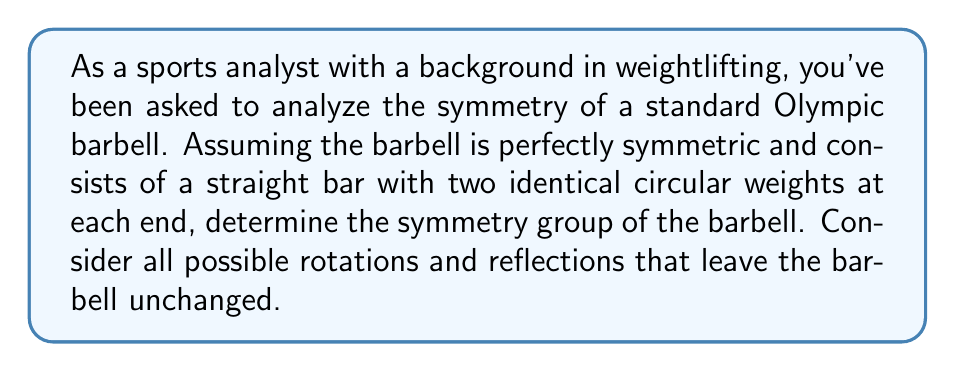What is the answer to this math problem? Let's approach this step-by-step:

1) First, we need to consider the symmetries of the barbell:

   a) Rotations:
      - The barbell can be rotated 360° around its long axis (the axis running through the center of the bar).
      - It can also be rotated 180° around any axis perpendicular to the long axis and passing through the center of the bar.

   b) Reflections:
      - There's a reflection plane perpendicular to the long axis at the center of the bar.
      - There are infinite reflection planes containing the long axis.

2) These symmetries form a group. Let's identify the group elements:
   - Identity (e): No rotation or reflection
   - $R_z$: Rotation by 360° around the long axis (z-axis)
   - $R_x$: Rotation by 180° around the x-axis (perpendicular to z)
   - $R_y$: Rotation by 180° around the y-axis (perpendicular to z and x)
   - $\sigma_{xy}$: Reflection in the xy-plane (perpendicular to z)
   - $\sigma_{xz}$: Reflection in the xz-plane
   - $\sigma_{yz}$: Reflection in the yz-plane

3) This group has 8 elements in total. The multiplication table of this group matches that of the D2h point group, also known as the orthorhombic group.

4) The D2h group is isomorphic to the direct product of three C2 groups:
   $$D_{2h} \cong C_2 \times C_2 \times C_2$$

   Where C2 is the cyclic group of order 2.

5) This group can also be described as:
   $$D_{2h} = \{e, R_x, R_y, R_z, \sigma_{xy}, \sigma_{xz}, \sigma_{yz}, i\}$$

   Where $i = R_x R_y R_z$ is the inversion operation.
Answer: The symmetry group of the barbell is the D2h point group (orthorhombic group), which is isomorphic to $C_2 \times C_2 \times C_2$. 